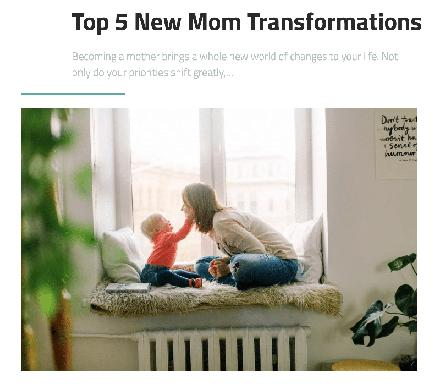What is the main topic of the text on the image? The main topic of the text is "Top 5 New Mom Transformations" and it discusses the changes that come into one's life when becoming a mother. What does the text say about priorities after becoming a mother? The text says that once a woman becomes a mother, her priorities shift greatly. 